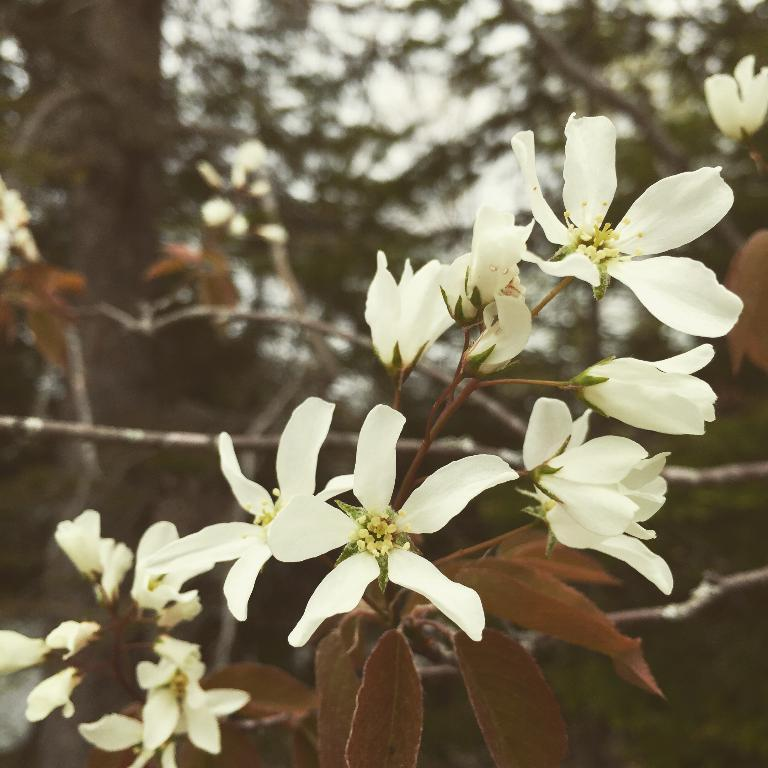What type of plant can be seen in the image? There are branches with leaves and white flowers in the image. What can be seen in the background of the image? There are trees in the background of the image. What type of window can be seen in the image? There is no window present in the image; it features branches with leaves and white flowers, as well as trees in the background. 